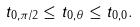<formula> <loc_0><loc_0><loc_500><loc_500>t _ { 0 , \pi / 2 } \leq t _ { 0 , \theta } \leq t _ { 0 , 0 } .</formula> 